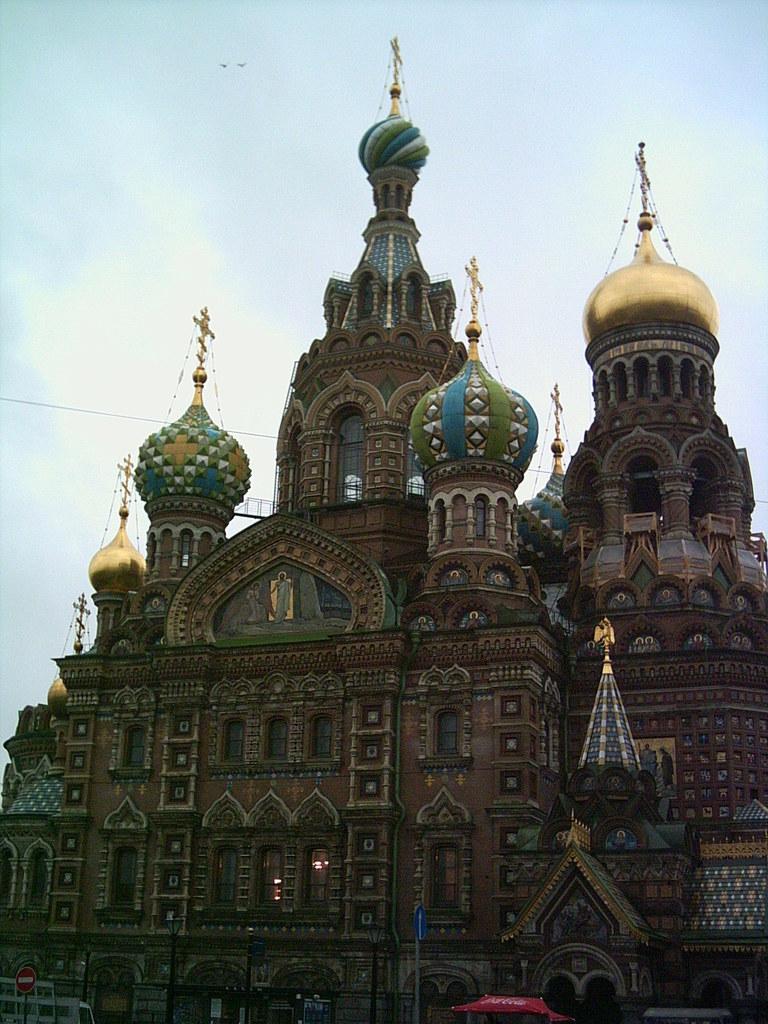In one or two sentences, can you explain what this image depicts? In this image there is a castle, in front of the castle there are sign boards and tents. 